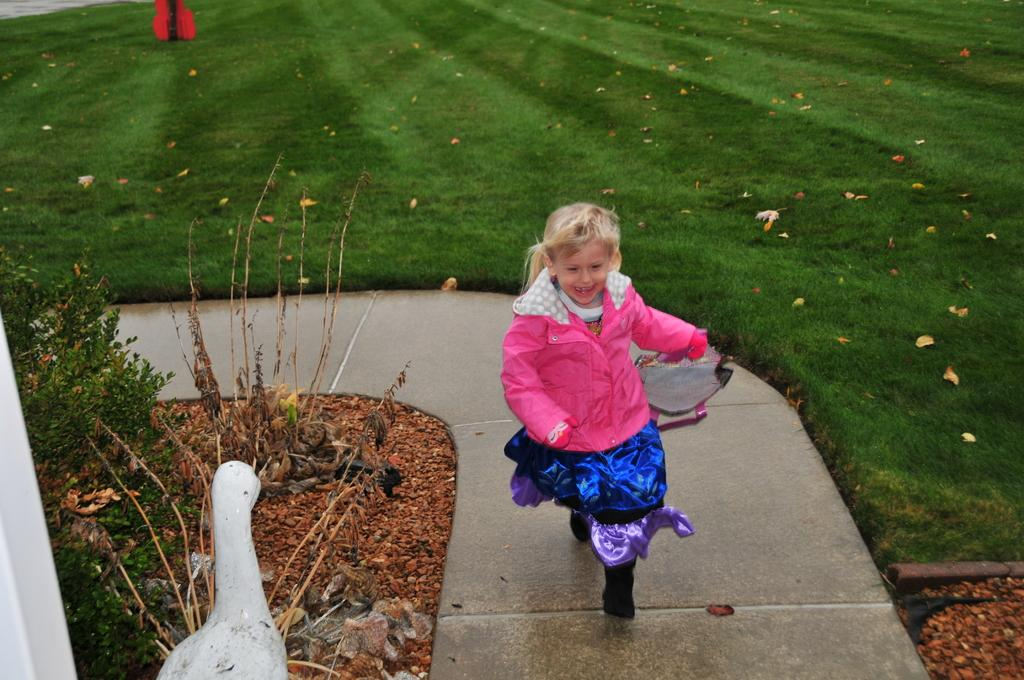What is the girl in the image doing? The girl is running in the image. On what surface is the girl running? The girl is running on a concrete platform. What object is beside the girl? There is a doll beside the girl. What type of vegetation is visible in the image? There are plants in the image. What type of material is present in the image? There are stones in the image. What can be seen in the background of the image? There is grass visible in the background of the image, and there is also an object in the background. How many circles can be seen in the image? There are no circles visible in the image. What type of cent is present in the image? There is no cent present in the image. 